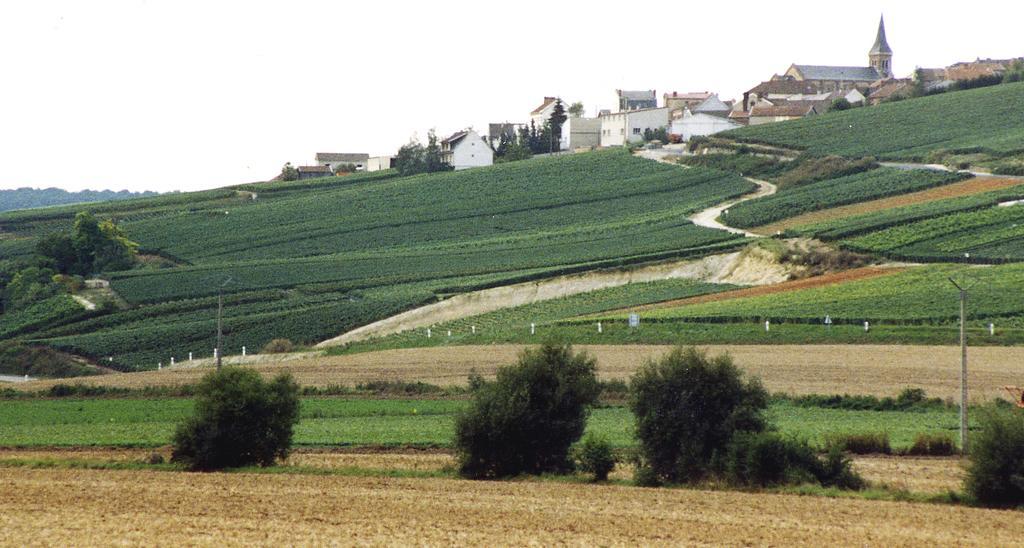How would you summarize this image in a sentence or two? In this image there are plants, trees, buildings, electrical poles and mountains. At the bottom of the image there is grass on the surface. At the top of the image there is sky. 